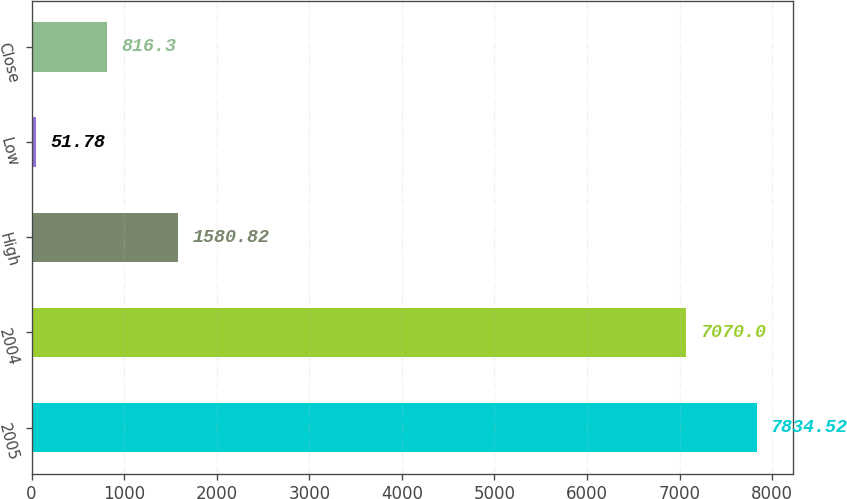Convert chart to OTSL. <chart><loc_0><loc_0><loc_500><loc_500><bar_chart><fcel>2005<fcel>2004<fcel>High<fcel>Low<fcel>Close<nl><fcel>7834.52<fcel>7070<fcel>1580.82<fcel>51.78<fcel>816.3<nl></chart> 